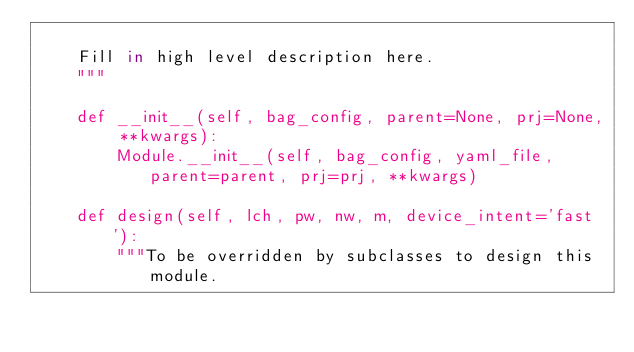<code> <loc_0><loc_0><loc_500><loc_500><_Python_>
    Fill in high level description here.
    """

    def __init__(self, bag_config, parent=None, prj=None, **kwargs):
        Module.__init__(self, bag_config, yaml_file, parent=parent, prj=prj, **kwargs)

    def design(self, lch, pw, nw, m, device_intent='fast'):
        """To be overridden by subclasses to design this module.
</code> 